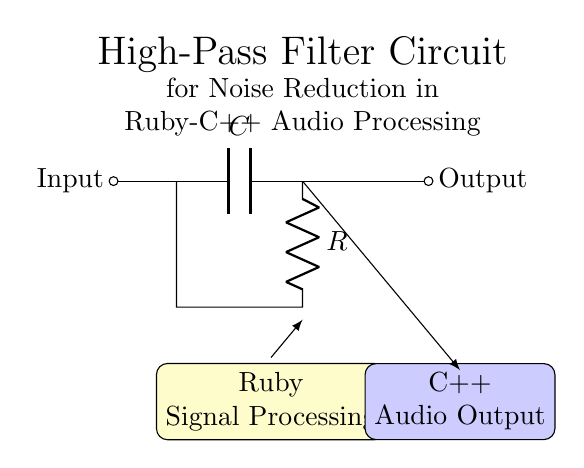What is the type of filter shown in the circuit? The circuit diagram represents a high-pass filter, as indicated by the arrangement of the capacitor and resistor. A high-pass filter allows high-frequency signals to pass while attenuating low-frequency signals.
Answer: high-pass filter What components are used in this circuit? This circuit includes a capacitor and a resistor. The capacitor is labeled C, and the resistor is labeled R, which are standard components used in creating filters.
Answer: capacitor and resistor What is the purpose of this circuit? The purpose of this circuit is noise reduction in audio processing applications, as indicated in the title of the diagram. High-pass filters are commonly used for this function.
Answer: noise reduction How are Ruby and C++ integrated in this circuit? Ruby is used for signal processing, which relates to the input side of the circuit, while C++ is utilized for audio output, shown on the output side. The diagram illustrates the flow of data from Ruby to C++.
Answer: Ruby for processing, C++ for output What is the connection from the output of the filter? The output of the filter is connected to an audio output system, indicated by the label on the right side of the circuit. The output flows directly after the resistor.
Answer: audio output What is the function of the capacitor in this filter? The capacitor in a high-pass filter blocks low-frequency signals and allows high-frequency signals to pass through to the output. This is a key function for achieving the desired filtering effect.
Answer: blocks low frequencies What happens if the capacitor is removed from this circuit? If the capacitor is removed, the circuit will no longer function as a high-pass filter; instead, it will allow both high and low frequencies to pass without attenuation, resulting in a loss of the noise reduction function.
Answer: circuit becomes a short 